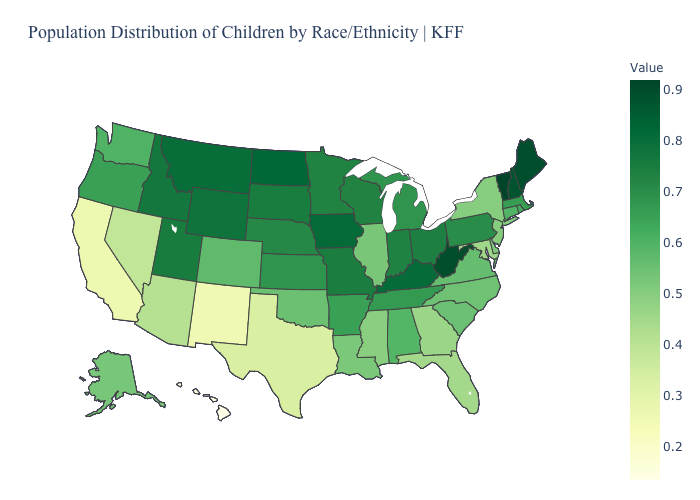Among the states that border Wisconsin , which have the lowest value?
Concise answer only. Illinois. Does Michigan have a higher value than Alaska?
Write a very short answer. Yes. Does West Virginia have the highest value in the South?
Give a very brief answer. Yes. Among the states that border Alabama , does Tennessee have the highest value?
Be succinct. Yes. Among the states that border South Carolina , does Georgia have the highest value?
Answer briefly. No. 